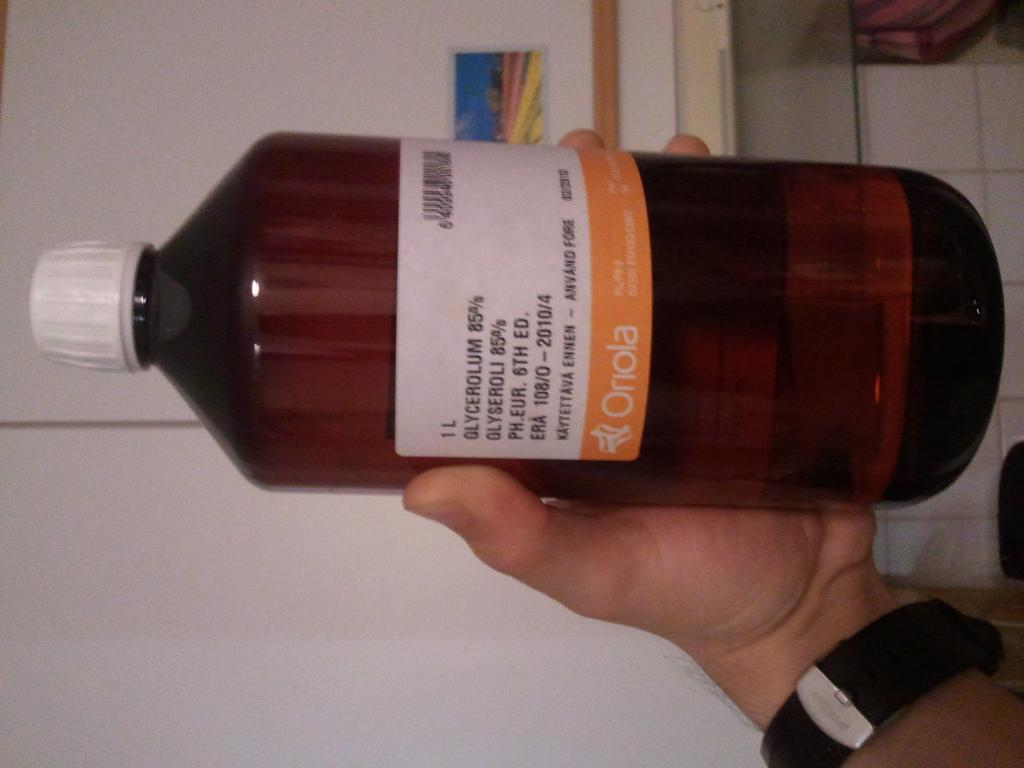Provide a one-sentence caption for the provided image. a bottle of medicine made by the company oriola. 